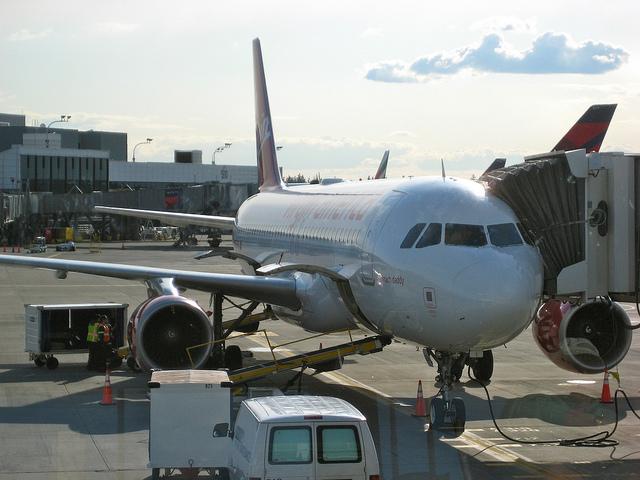What type of vehicle is this?
Keep it brief. Airplane. Where was the picture taken of the airplane?
Give a very brief answer. Airport. Is this a virgin America airlines?
Give a very brief answer. Yes. How many engines are on this plane?
Give a very brief answer. 2. 